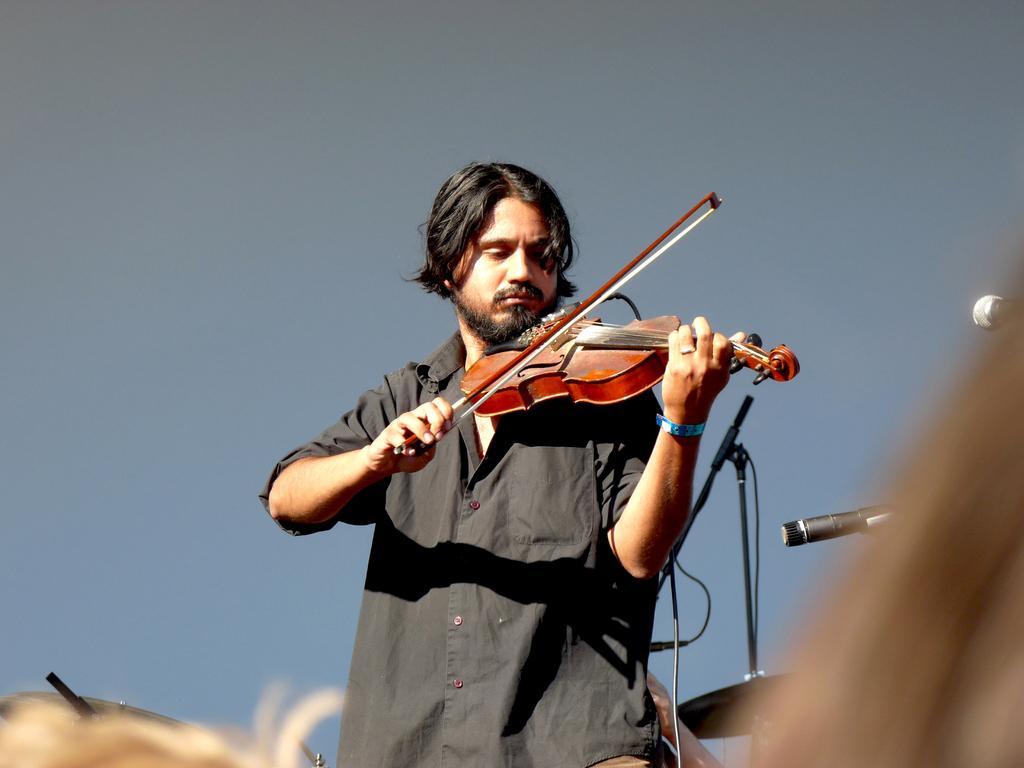How would you summarize this image in a sentence or two? There is a person in black color shirt, holding a violin and playing and standing on a stage, near a mic, which is attached to the stand. In the background, there are other musical instruments and the background is blue in color. 